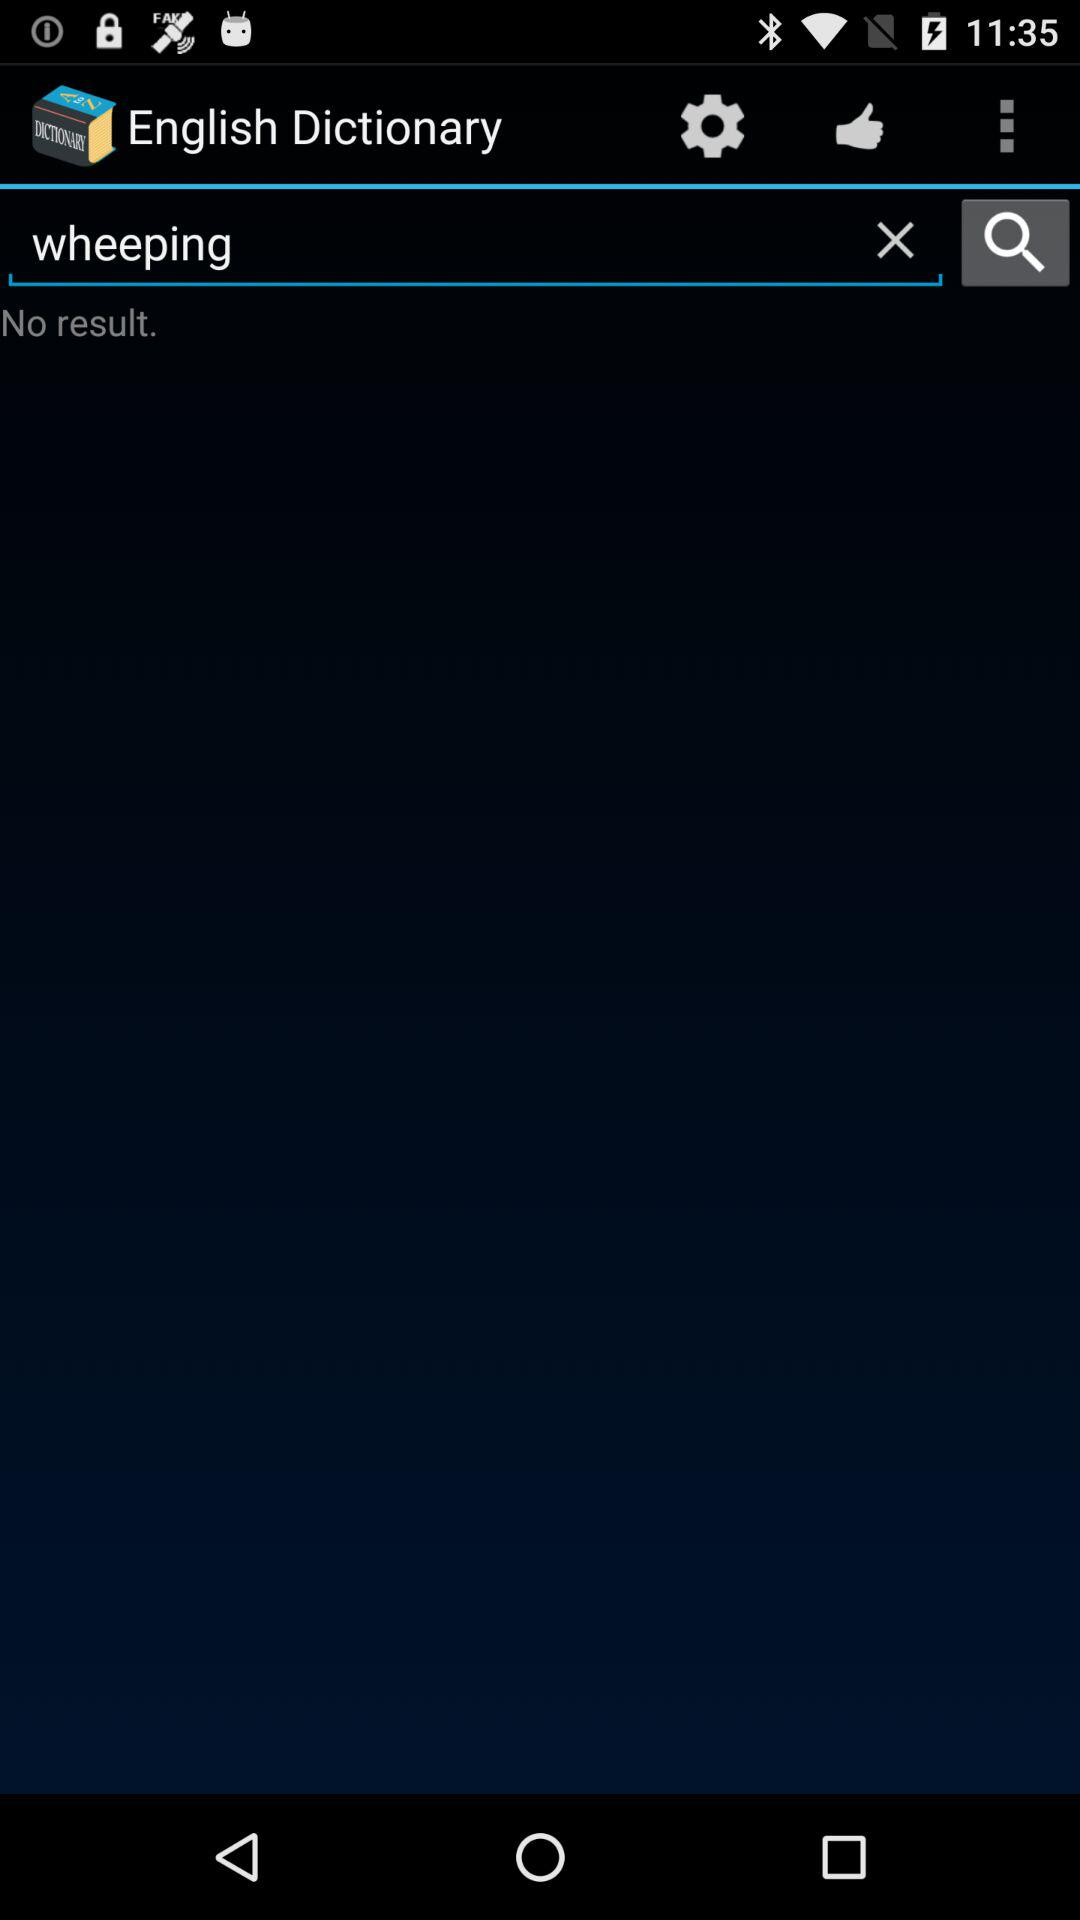How is "wheeping" defined?
When the provided information is insufficient, respond with <no answer>. <no answer> 